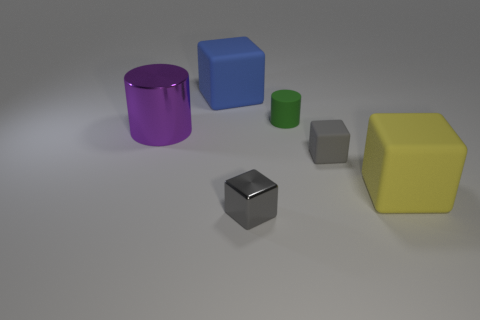Subtract all gray matte blocks. How many blocks are left? 3 Add 4 green rubber things. How many objects exist? 10 Subtract all blue cubes. How many cubes are left? 3 Subtract all cylinders. How many objects are left? 4 Subtract all yellow spheres. How many gray cubes are left? 2 Subtract all purple cylinders. Subtract all gray balls. How many cylinders are left? 1 Subtract all tiny things. Subtract all yellow blocks. How many objects are left? 2 Add 5 small green rubber cylinders. How many small green rubber cylinders are left? 6 Add 6 tiny blue cylinders. How many tiny blue cylinders exist? 6 Subtract 0 brown cylinders. How many objects are left? 6 